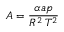Convert formula to latex. <formula><loc_0><loc_0><loc_500><loc_500>A = { \frac { \alpha a p } { R ^ { 2 } \, T ^ { 2 } } }</formula> 